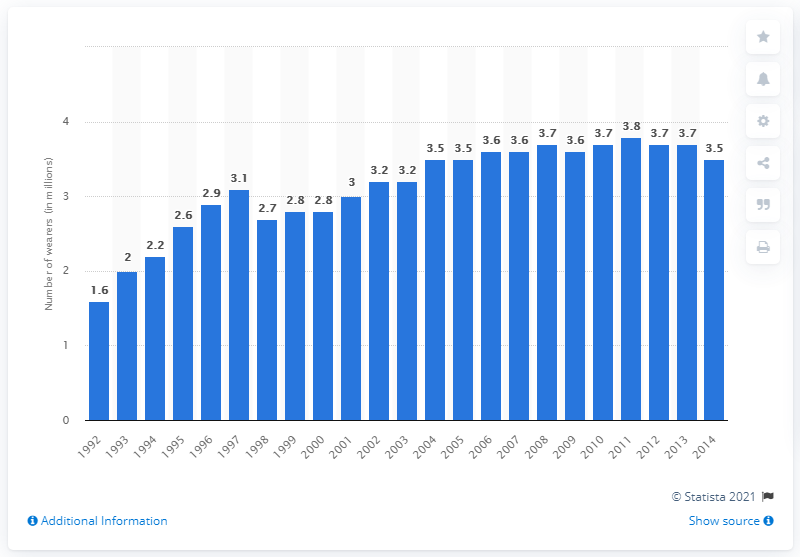Draw attention to some important aspects in this diagram. In 1992, it is estimated that approximately 1.6 million people in the United Kingdom and the Republic of Ireland wore contact lenses. In 2014, an estimated 3.5 million people in the UK and Ireland were wearing contact lenses. 